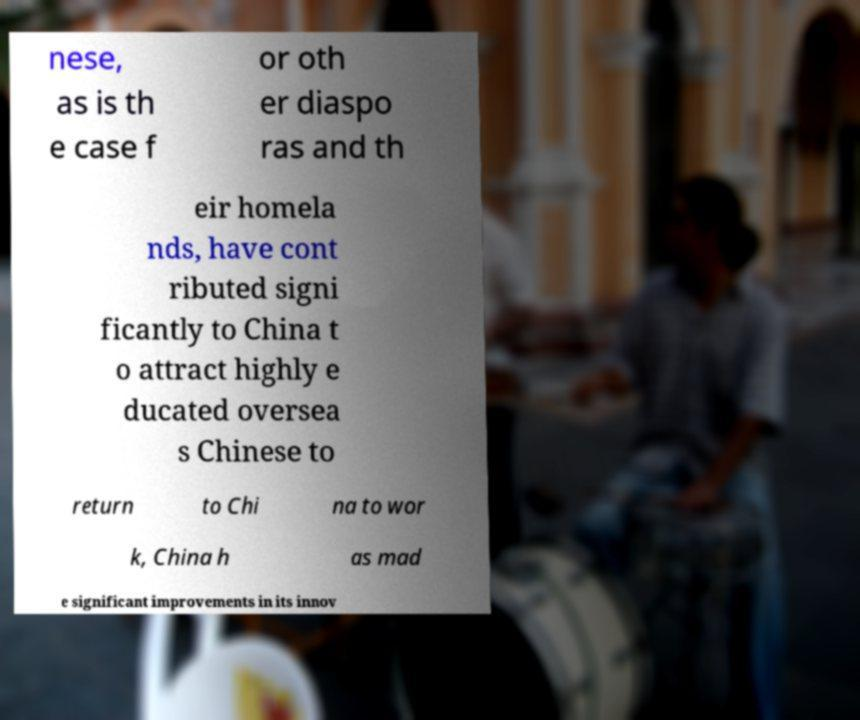I need the written content from this picture converted into text. Can you do that? nese, as is th e case f or oth er diaspo ras and th eir homela nds, have cont ributed signi ficantly to China t o attract highly e ducated oversea s Chinese to return to Chi na to wor k, China h as mad e significant improvements in its innov 